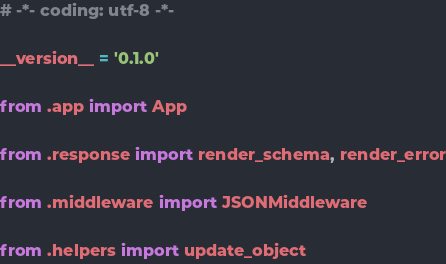Convert code to text. <code><loc_0><loc_0><loc_500><loc_500><_Python_># -*- coding: utf-8 -*-

__version__ = '0.1.0'

from .app import App

from .response import render_schema, render_error

from .middleware import JSONMiddleware

from .helpers import update_object
</code> 